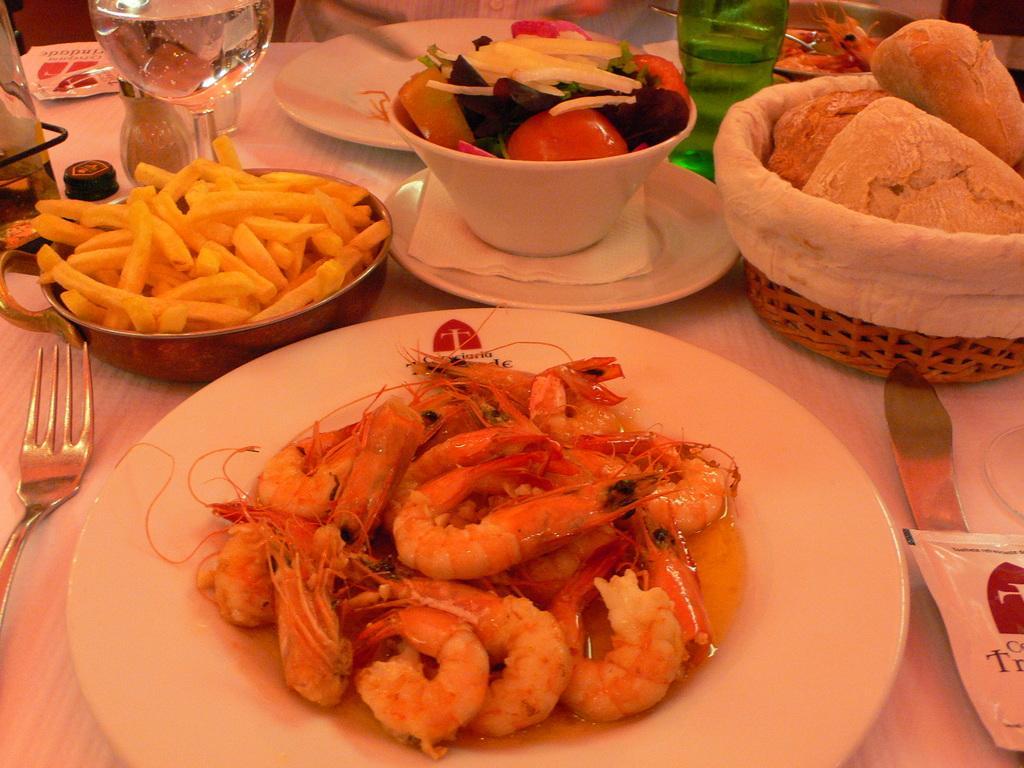Please provide a concise description of this image. In this image, we can see food items, plates, bowls, a bottle, a glass with drink, forks, a spoon and a basket, some packets, some tissues and some other objects are on the table and we can see a person, in the background. 